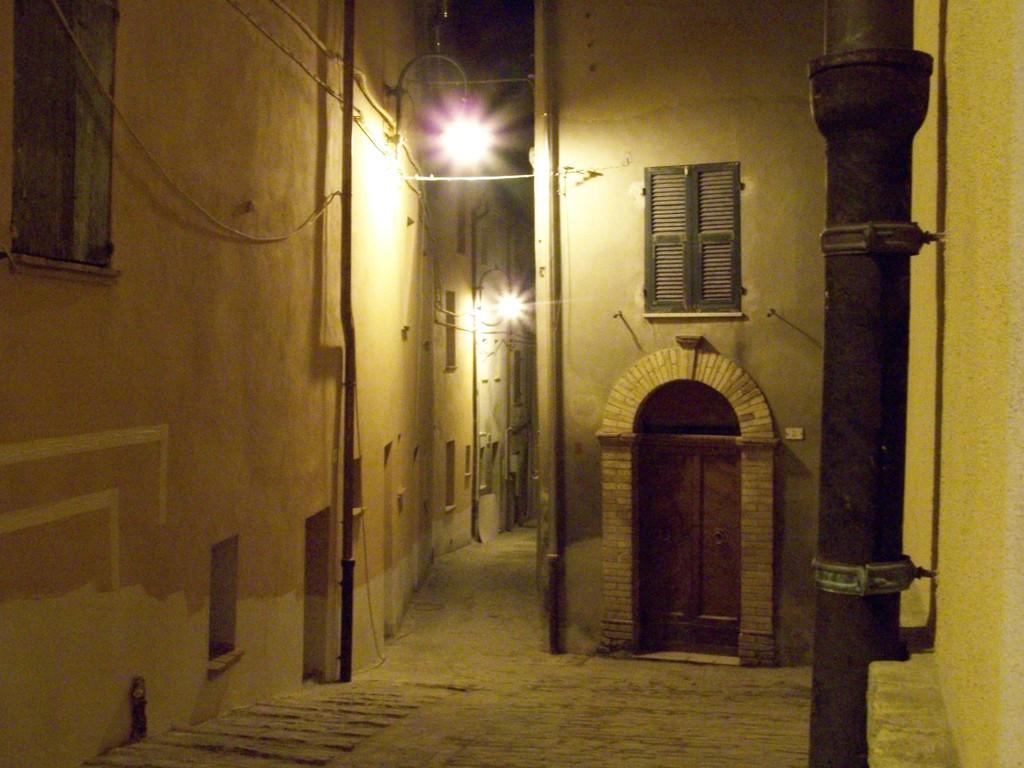Describe this image in one or two sentences. In this image we can see walls, ropes, poles, pipelines, street poles, street lights and a door. 